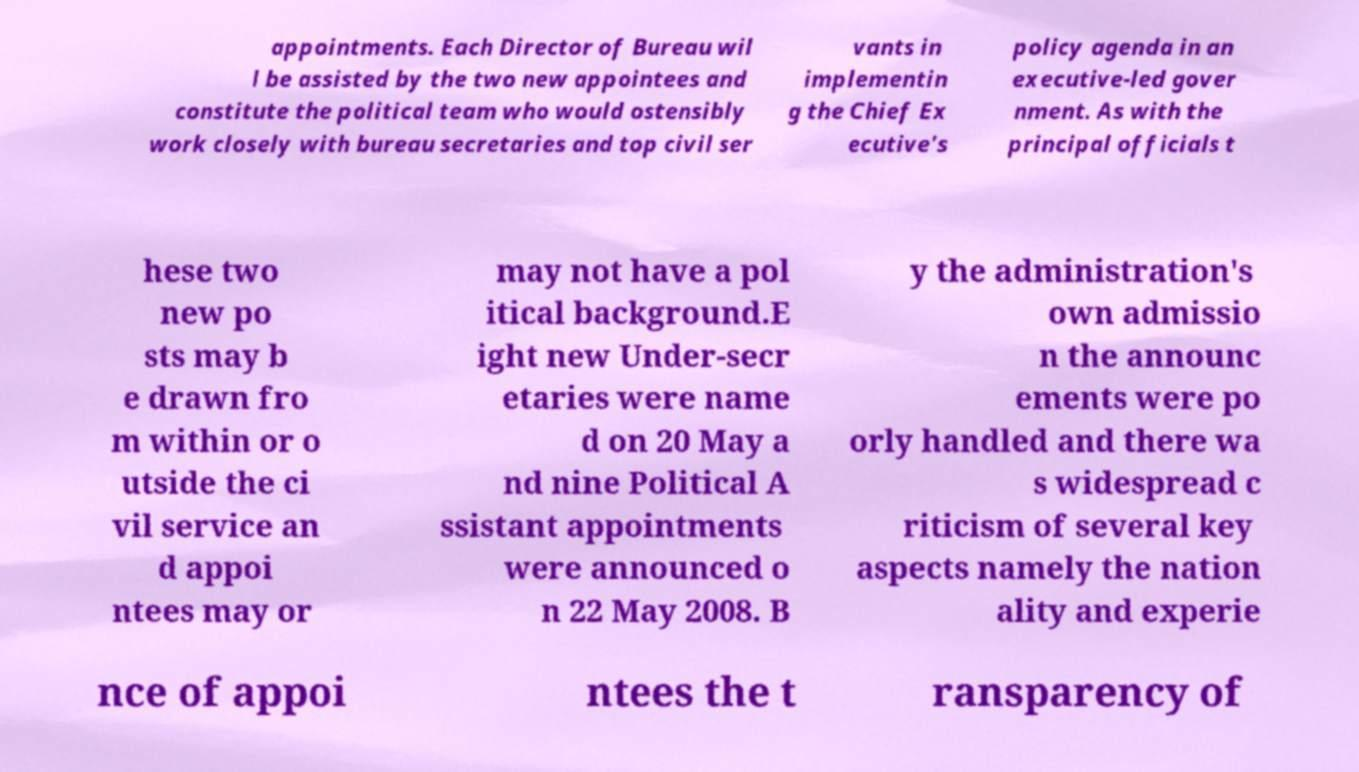There's text embedded in this image that I need extracted. Can you transcribe it verbatim? appointments. Each Director of Bureau wil l be assisted by the two new appointees and constitute the political team who would ostensibly work closely with bureau secretaries and top civil ser vants in implementin g the Chief Ex ecutive's policy agenda in an executive-led gover nment. As with the principal officials t hese two new po sts may b e drawn fro m within or o utside the ci vil service an d appoi ntees may or may not have a pol itical background.E ight new Under-secr etaries were name d on 20 May a nd nine Political A ssistant appointments were announced o n 22 May 2008. B y the administration's own admissio n the announc ements were po orly handled and there wa s widespread c riticism of several key aspects namely the nation ality and experie nce of appoi ntees the t ransparency of 